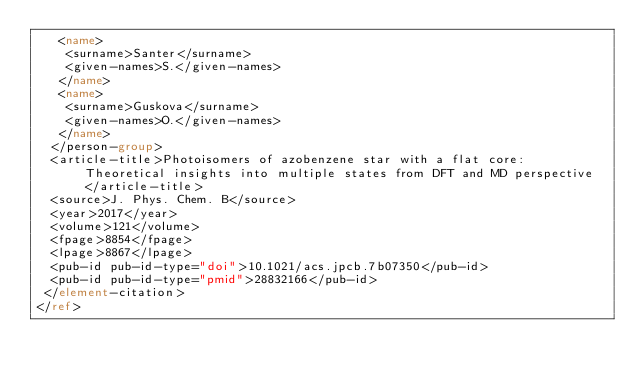<code> <loc_0><loc_0><loc_500><loc_500><_XML_>   <name>
    <surname>Santer</surname>
    <given-names>S.</given-names>
   </name>
   <name>
    <surname>Guskova</surname>
    <given-names>O.</given-names>
   </name>
  </person-group>
  <article-title>Photoisomers of azobenzene star with a flat core: Theoretical insights into multiple states from DFT and MD perspective</article-title>
  <source>J. Phys. Chem. B</source>
  <year>2017</year>
  <volume>121</volume>
  <fpage>8854</fpage>
  <lpage>8867</lpage>
  <pub-id pub-id-type="doi">10.1021/acs.jpcb.7b07350</pub-id>
  <pub-id pub-id-type="pmid">28832166</pub-id>
 </element-citation>
</ref>
</code> 